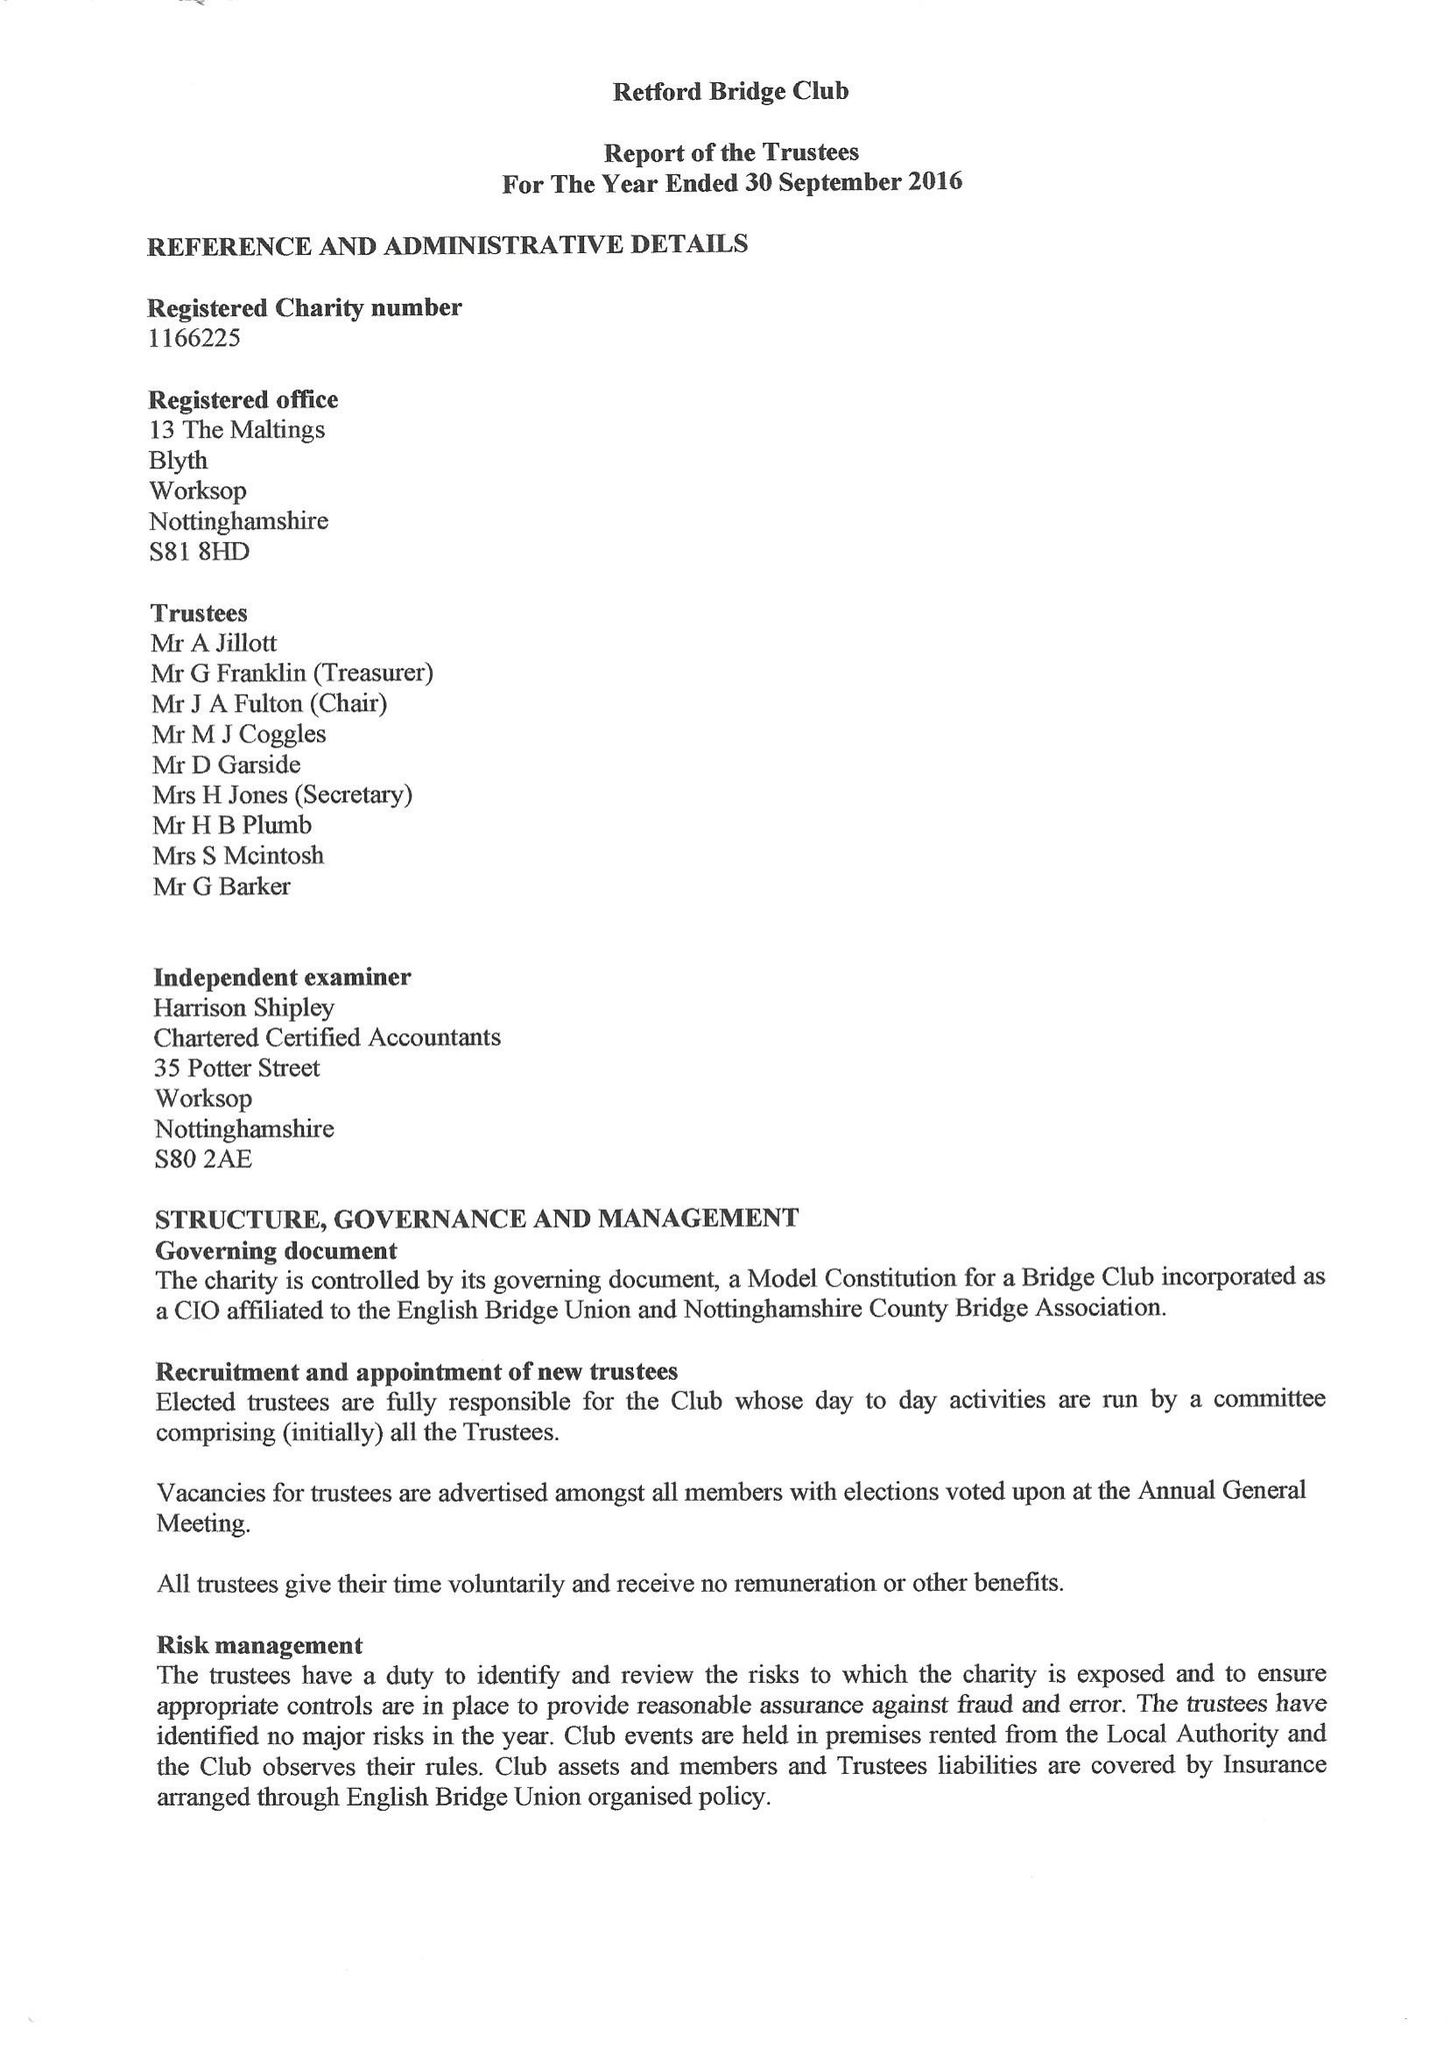What is the value for the spending_annually_in_british_pounds?
Answer the question using a single word or phrase. 7638.00 